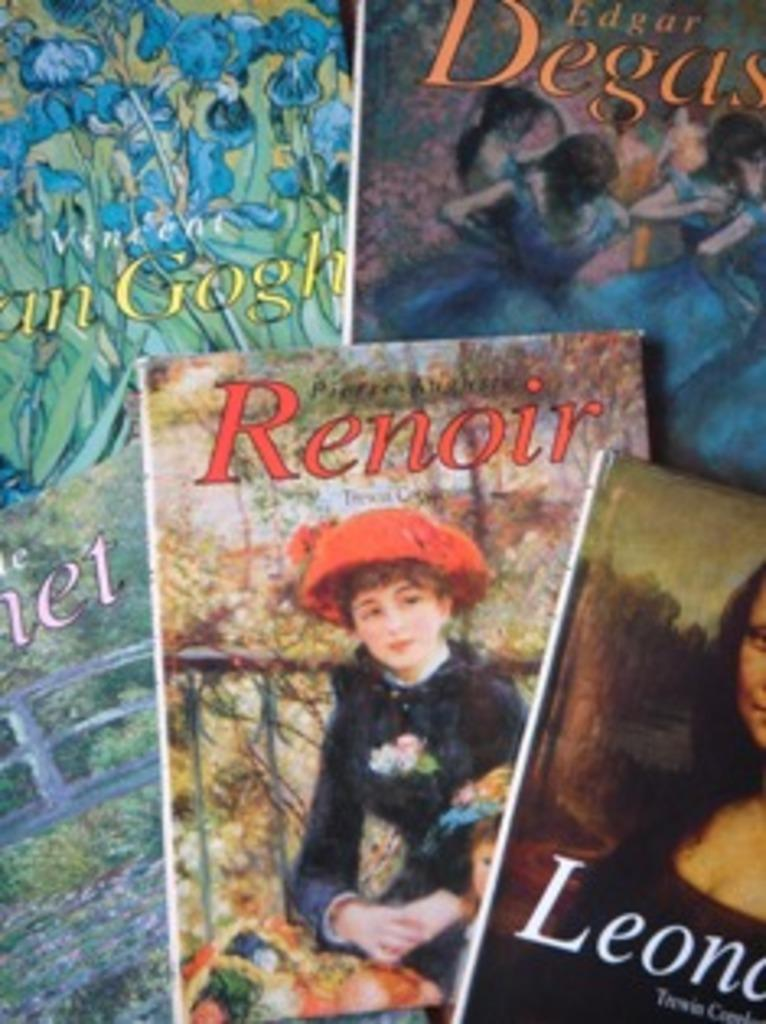Provide a one-sentence caption for the provided image. A few magazines placed together one named Renoir. 